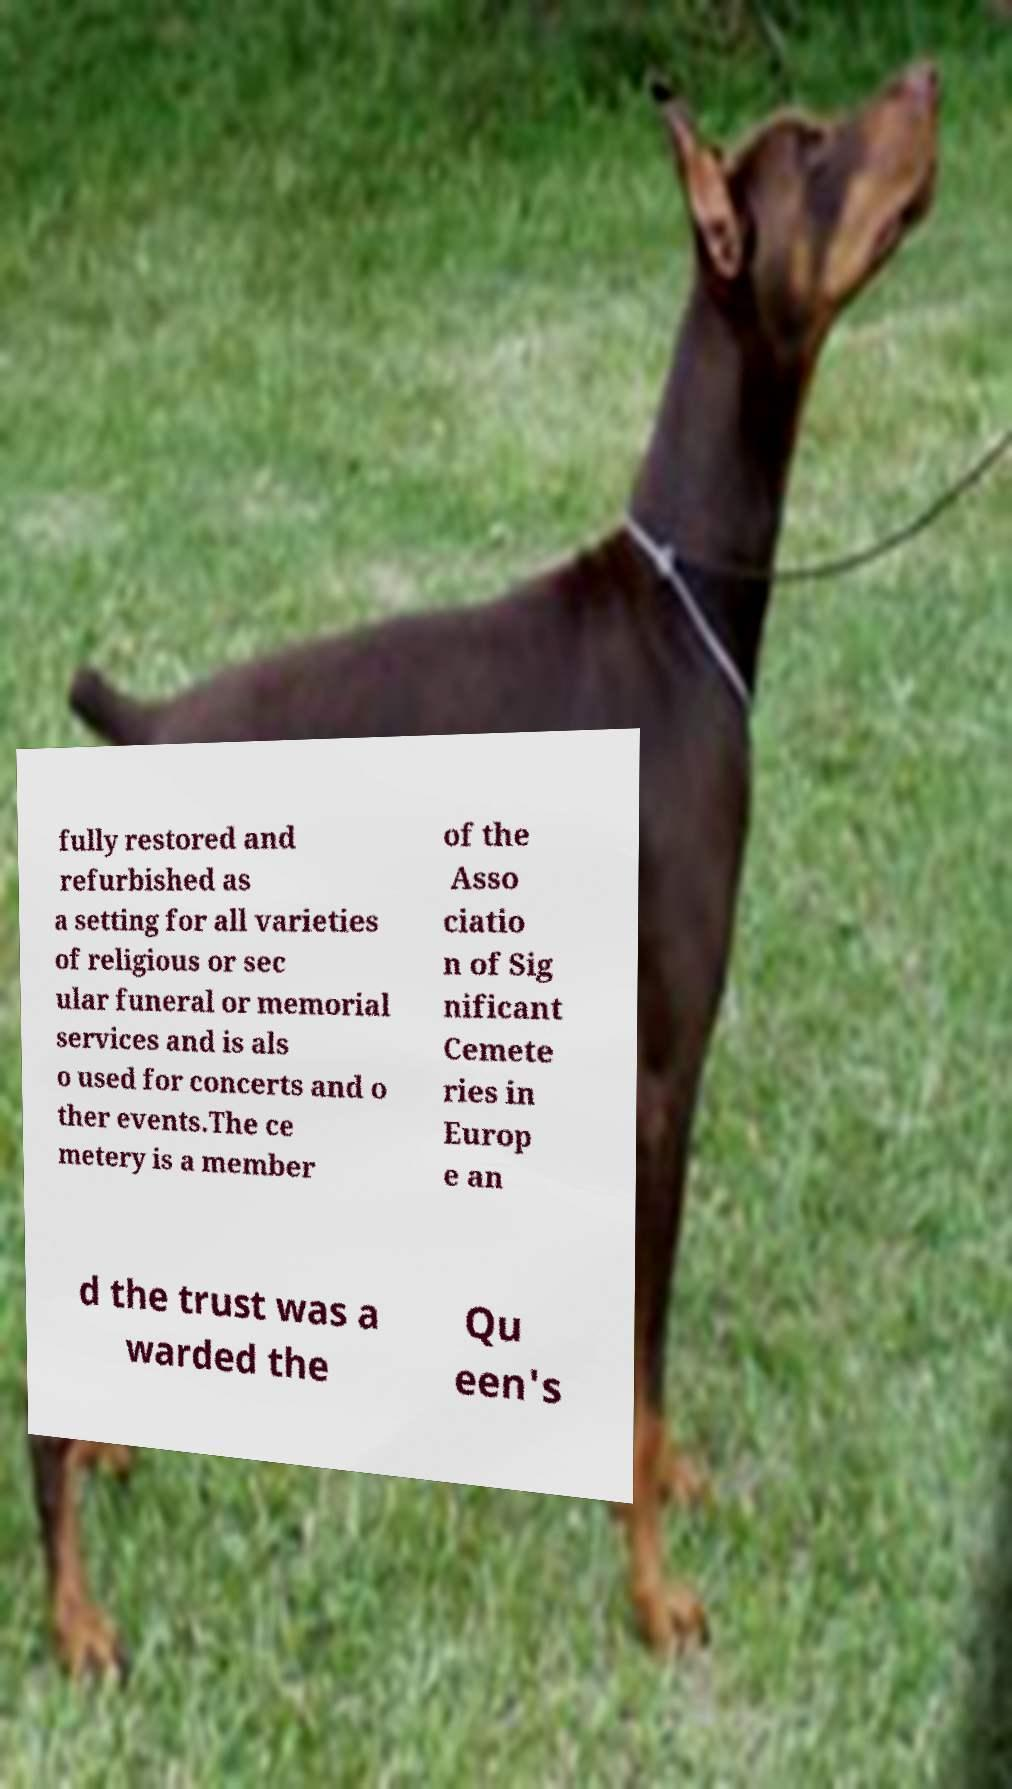Could you assist in decoding the text presented in this image and type it out clearly? fully restored and refurbished as a setting for all varieties of religious or sec ular funeral or memorial services and is als o used for concerts and o ther events.The ce metery is a member of the Asso ciatio n of Sig nificant Cemete ries in Europ e an d the trust was a warded the Qu een's 